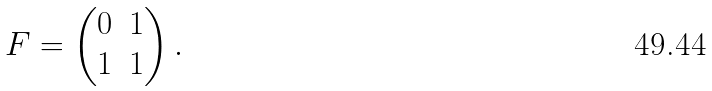Convert formula to latex. <formula><loc_0><loc_0><loc_500><loc_500>F = \begin{pmatrix} 0 & 1 \\ 1 & 1 \\ \end{pmatrix} .</formula> 